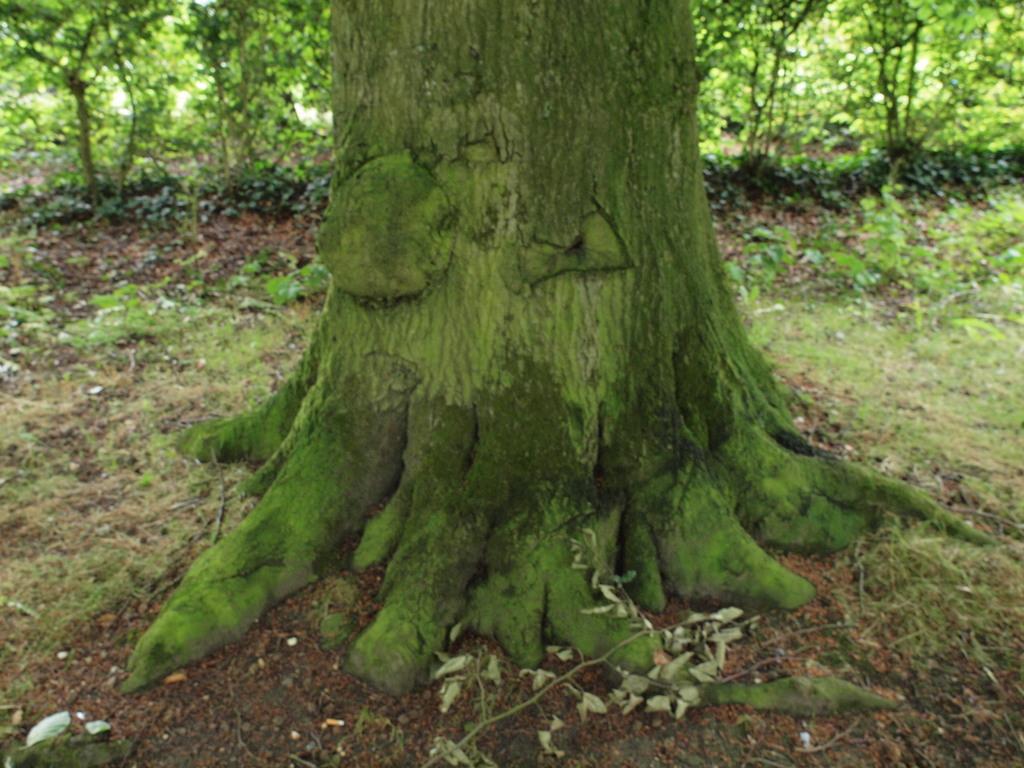Please provide a concise description of this image. In this image we can see a tree trunk. In the background there are trees. 